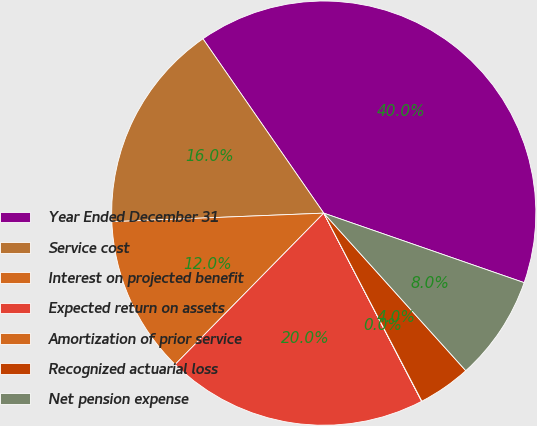Convert chart to OTSL. <chart><loc_0><loc_0><loc_500><loc_500><pie_chart><fcel>Year Ended December 31<fcel>Service cost<fcel>Interest on projected benefit<fcel>Expected return on assets<fcel>Amortization of prior service<fcel>Recognized actuarial loss<fcel>Net pension expense<nl><fcel>39.96%<fcel>16.0%<fcel>12.0%<fcel>19.99%<fcel>0.02%<fcel>4.02%<fcel>8.01%<nl></chart> 